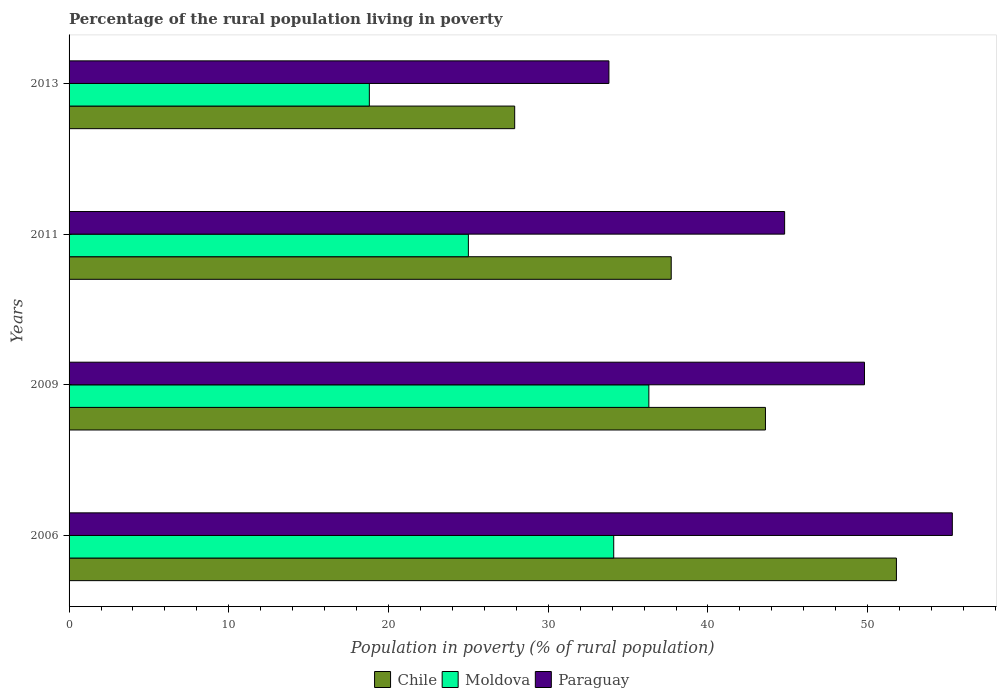How many different coloured bars are there?
Provide a short and direct response. 3. How many groups of bars are there?
Your answer should be compact. 4. Are the number of bars per tick equal to the number of legend labels?
Keep it short and to the point. Yes. Are the number of bars on each tick of the Y-axis equal?
Provide a succinct answer. Yes. What is the label of the 2nd group of bars from the top?
Offer a terse response. 2011. In how many cases, is the number of bars for a given year not equal to the number of legend labels?
Offer a terse response. 0. What is the percentage of the rural population living in poverty in Moldova in 2011?
Your answer should be compact. 25. Across all years, what is the maximum percentage of the rural population living in poverty in Moldova?
Provide a short and direct response. 36.3. Across all years, what is the minimum percentage of the rural population living in poverty in Chile?
Provide a short and direct response. 27.9. In which year was the percentage of the rural population living in poverty in Chile maximum?
Provide a short and direct response. 2006. In which year was the percentage of the rural population living in poverty in Moldova minimum?
Your answer should be very brief. 2013. What is the total percentage of the rural population living in poverty in Chile in the graph?
Offer a terse response. 161. What is the difference between the percentage of the rural population living in poverty in Chile in 2011 and that in 2013?
Offer a terse response. 9.8. What is the average percentage of the rural population living in poverty in Paraguay per year?
Provide a short and direct response. 45.92. In the year 2011, what is the difference between the percentage of the rural population living in poverty in Moldova and percentage of the rural population living in poverty in Chile?
Your answer should be compact. -12.7. In how many years, is the percentage of the rural population living in poverty in Paraguay greater than 56 %?
Your answer should be very brief. 0. What is the ratio of the percentage of the rural population living in poverty in Paraguay in 2009 to that in 2013?
Offer a very short reply. 1.47. Is the percentage of the rural population living in poverty in Paraguay in 2006 less than that in 2013?
Ensure brevity in your answer.  No. Is the difference between the percentage of the rural population living in poverty in Moldova in 2006 and 2013 greater than the difference between the percentage of the rural population living in poverty in Chile in 2006 and 2013?
Keep it short and to the point. No. What is the difference between the highest and the second highest percentage of the rural population living in poverty in Chile?
Your response must be concise. 8.2. What is the difference between the highest and the lowest percentage of the rural population living in poverty in Moldova?
Give a very brief answer. 17.5. In how many years, is the percentage of the rural population living in poverty in Moldova greater than the average percentage of the rural population living in poverty in Moldova taken over all years?
Provide a succinct answer. 2. Is the sum of the percentage of the rural population living in poverty in Chile in 2011 and 2013 greater than the maximum percentage of the rural population living in poverty in Paraguay across all years?
Offer a terse response. Yes. What does the 2nd bar from the top in 2013 represents?
Offer a very short reply. Moldova. What does the 3rd bar from the bottom in 2013 represents?
Keep it short and to the point. Paraguay. Is it the case that in every year, the sum of the percentage of the rural population living in poverty in Moldova and percentage of the rural population living in poverty in Paraguay is greater than the percentage of the rural population living in poverty in Chile?
Ensure brevity in your answer.  Yes. How many bars are there?
Your answer should be very brief. 12. Are all the bars in the graph horizontal?
Your answer should be compact. Yes. How many years are there in the graph?
Provide a short and direct response. 4. Does the graph contain any zero values?
Offer a terse response. No. Where does the legend appear in the graph?
Ensure brevity in your answer.  Bottom center. How many legend labels are there?
Offer a very short reply. 3. What is the title of the graph?
Ensure brevity in your answer.  Percentage of the rural population living in poverty. Does "Papua New Guinea" appear as one of the legend labels in the graph?
Provide a short and direct response. No. What is the label or title of the X-axis?
Offer a very short reply. Population in poverty (% of rural population). What is the label or title of the Y-axis?
Provide a short and direct response. Years. What is the Population in poverty (% of rural population) of Chile in 2006?
Ensure brevity in your answer.  51.8. What is the Population in poverty (% of rural population) of Moldova in 2006?
Provide a short and direct response. 34.1. What is the Population in poverty (% of rural population) in Paraguay in 2006?
Your answer should be compact. 55.3. What is the Population in poverty (% of rural population) of Chile in 2009?
Offer a terse response. 43.6. What is the Population in poverty (% of rural population) in Moldova in 2009?
Make the answer very short. 36.3. What is the Population in poverty (% of rural population) in Paraguay in 2009?
Provide a succinct answer. 49.8. What is the Population in poverty (% of rural population) of Chile in 2011?
Give a very brief answer. 37.7. What is the Population in poverty (% of rural population) of Moldova in 2011?
Keep it short and to the point. 25. What is the Population in poverty (% of rural population) in Paraguay in 2011?
Make the answer very short. 44.8. What is the Population in poverty (% of rural population) in Chile in 2013?
Keep it short and to the point. 27.9. What is the Population in poverty (% of rural population) of Paraguay in 2013?
Your response must be concise. 33.8. Across all years, what is the maximum Population in poverty (% of rural population) in Chile?
Keep it short and to the point. 51.8. Across all years, what is the maximum Population in poverty (% of rural population) in Moldova?
Give a very brief answer. 36.3. Across all years, what is the maximum Population in poverty (% of rural population) in Paraguay?
Keep it short and to the point. 55.3. Across all years, what is the minimum Population in poverty (% of rural population) in Chile?
Provide a succinct answer. 27.9. Across all years, what is the minimum Population in poverty (% of rural population) of Moldova?
Your response must be concise. 18.8. Across all years, what is the minimum Population in poverty (% of rural population) in Paraguay?
Offer a very short reply. 33.8. What is the total Population in poverty (% of rural population) of Chile in the graph?
Your answer should be very brief. 161. What is the total Population in poverty (% of rural population) of Moldova in the graph?
Provide a succinct answer. 114.2. What is the total Population in poverty (% of rural population) of Paraguay in the graph?
Provide a short and direct response. 183.7. What is the difference between the Population in poverty (% of rural population) in Moldova in 2006 and that in 2011?
Provide a short and direct response. 9.1. What is the difference between the Population in poverty (% of rural population) in Chile in 2006 and that in 2013?
Ensure brevity in your answer.  23.9. What is the difference between the Population in poverty (% of rural population) of Moldova in 2006 and that in 2013?
Ensure brevity in your answer.  15.3. What is the difference between the Population in poverty (% of rural population) of Paraguay in 2006 and that in 2013?
Give a very brief answer. 21.5. What is the difference between the Population in poverty (% of rural population) in Chile in 2009 and that in 2011?
Provide a short and direct response. 5.9. What is the difference between the Population in poverty (% of rural population) of Moldova in 2009 and that in 2011?
Make the answer very short. 11.3. What is the difference between the Population in poverty (% of rural population) in Paraguay in 2009 and that in 2011?
Your answer should be very brief. 5. What is the difference between the Population in poverty (% of rural population) of Chile in 2006 and the Population in poverty (% of rural population) of Paraguay in 2009?
Make the answer very short. 2. What is the difference between the Population in poverty (% of rural population) in Moldova in 2006 and the Population in poverty (% of rural population) in Paraguay in 2009?
Provide a short and direct response. -15.7. What is the difference between the Population in poverty (% of rural population) of Chile in 2006 and the Population in poverty (% of rural population) of Moldova in 2011?
Ensure brevity in your answer.  26.8. What is the difference between the Population in poverty (% of rural population) of Chile in 2006 and the Population in poverty (% of rural population) of Paraguay in 2011?
Your answer should be compact. 7. What is the difference between the Population in poverty (% of rural population) in Moldova in 2006 and the Population in poverty (% of rural population) in Paraguay in 2011?
Give a very brief answer. -10.7. What is the difference between the Population in poverty (% of rural population) of Moldova in 2006 and the Population in poverty (% of rural population) of Paraguay in 2013?
Give a very brief answer. 0.3. What is the difference between the Population in poverty (% of rural population) of Chile in 2009 and the Population in poverty (% of rural population) of Moldova in 2011?
Provide a succinct answer. 18.6. What is the difference between the Population in poverty (% of rural population) in Chile in 2009 and the Population in poverty (% of rural population) in Moldova in 2013?
Offer a very short reply. 24.8. What is the difference between the Population in poverty (% of rural population) of Moldova in 2009 and the Population in poverty (% of rural population) of Paraguay in 2013?
Your response must be concise. 2.5. What is the difference between the Population in poverty (% of rural population) in Chile in 2011 and the Population in poverty (% of rural population) in Moldova in 2013?
Your answer should be compact. 18.9. What is the difference between the Population in poverty (% of rural population) in Moldova in 2011 and the Population in poverty (% of rural population) in Paraguay in 2013?
Ensure brevity in your answer.  -8.8. What is the average Population in poverty (% of rural population) of Chile per year?
Provide a short and direct response. 40.25. What is the average Population in poverty (% of rural population) in Moldova per year?
Ensure brevity in your answer.  28.55. What is the average Population in poverty (% of rural population) of Paraguay per year?
Provide a succinct answer. 45.92. In the year 2006, what is the difference between the Population in poverty (% of rural population) in Chile and Population in poverty (% of rural population) in Moldova?
Give a very brief answer. 17.7. In the year 2006, what is the difference between the Population in poverty (% of rural population) of Moldova and Population in poverty (% of rural population) of Paraguay?
Make the answer very short. -21.2. In the year 2009, what is the difference between the Population in poverty (% of rural population) in Chile and Population in poverty (% of rural population) in Moldova?
Make the answer very short. 7.3. In the year 2009, what is the difference between the Population in poverty (% of rural population) of Chile and Population in poverty (% of rural population) of Paraguay?
Make the answer very short. -6.2. In the year 2009, what is the difference between the Population in poverty (% of rural population) in Moldova and Population in poverty (% of rural population) in Paraguay?
Your response must be concise. -13.5. In the year 2011, what is the difference between the Population in poverty (% of rural population) of Chile and Population in poverty (% of rural population) of Moldova?
Provide a succinct answer. 12.7. In the year 2011, what is the difference between the Population in poverty (% of rural population) of Chile and Population in poverty (% of rural population) of Paraguay?
Your answer should be compact. -7.1. In the year 2011, what is the difference between the Population in poverty (% of rural population) of Moldova and Population in poverty (% of rural population) of Paraguay?
Provide a short and direct response. -19.8. In the year 2013, what is the difference between the Population in poverty (% of rural population) in Moldova and Population in poverty (% of rural population) in Paraguay?
Provide a short and direct response. -15. What is the ratio of the Population in poverty (% of rural population) in Chile in 2006 to that in 2009?
Your response must be concise. 1.19. What is the ratio of the Population in poverty (% of rural population) of Moldova in 2006 to that in 2009?
Provide a short and direct response. 0.94. What is the ratio of the Population in poverty (% of rural population) of Paraguay in 2006 to that in 2009?
Keep it short and to the point. 1.11. What is the ratio of the Population in poverty (% of rural population) of Chile in 2006 to that in 2011?
Make the answer very short. 1.37. What is the ratio of the Population in poverty (% of rural population) of Moldova in 2006 to that in 2011?
Your response must be concise. 1.36. What is the ratio of the Population in poverty (% of rural population) in Paraguay in 2006 to that in 2011?
Your response must be concise. 1.23. What is the ratio of the Population in poverty (% of rural population) in Chile in 2006 to that in 2013?
Your answer should be very brief. 1.86. What is the ratio of the Population in poverty (% of rural population) in Moldova in 2006 to that in 2013?
Your response must be concise. 1.81. What is the ratio of the Population in poverty (% of rural population) in Paraguay in 2006 to that in 2013?
Offer a terse response. 1.64. What is the ratio of the Population in poverty (% of rural population) of Chile in 2009 to that in 2011?
Offer a very short reply. 1.16. What is the ratio of the Population in poverty (% of rural population) in Moldova in 2009 to that in 2011?
Offer a terse response. 1.45. What is the ratio of the Population in poverty (% of rural population) in Paraguay in 2009 to that in 2011?
Your answer should be compact. 1.11. What is the ratio of the Population in poverty (% of rural population) of Chile in 2009 to that in 2013?
Make the answer very short. 1.56. What is the ratio of the Population in poverty (% of rural population) of Moldova in 2009 to that in 2013?
Your response must be concise. 1.93. What is the ratio of the Population in poverty (% of rural population) in Paraguay in 2009 to that in 2013?
Provide a short and direct response. 1.47. What is the ratio of the Population in poverty (% of rural population) of Chile in 2011 to that in 2013?
Your response must be concise. 1.35. What is the ratio of the Population in poverty (% of rural population) in Moldova in 2011 to that in 2013?
Keep it short and to the point. 1.33. What is the ratio of the Population in poverty (% of rural population) in Paraguay in 2011 to that in 2013?
Provide a short and direct response. 1.33. What is the difference between the highest and the second highest Population in poverty (% of rural population) in Chile?
Your response must be concise. 8.2. What is the difference between the highest and the lowest Population in poverty (% of rural population) of Chile?
Ensure brevity in your answer.  23.9. 